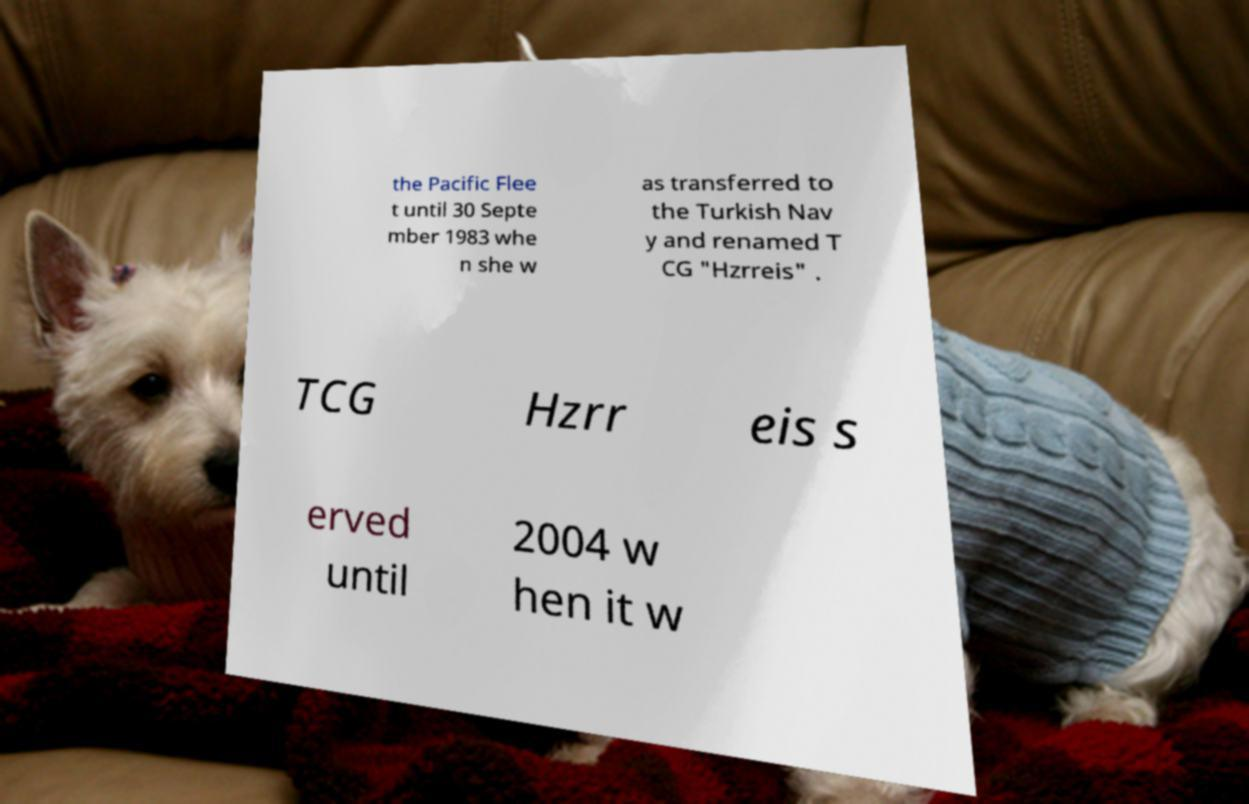Please identify and transcribe the text found in this image. the Pacific Flee t until 30 Septe mber 1983 whe n she w as transferred to the Turkish Nav y and renamed T CG "Hzrreis" . TCG Hzrr eis s erved until 2004 w hen it w 